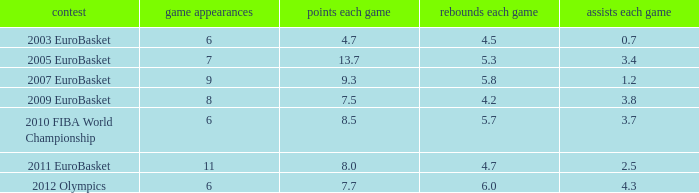How many points per game have the tournament 2005 eurobasket? 13.7. 